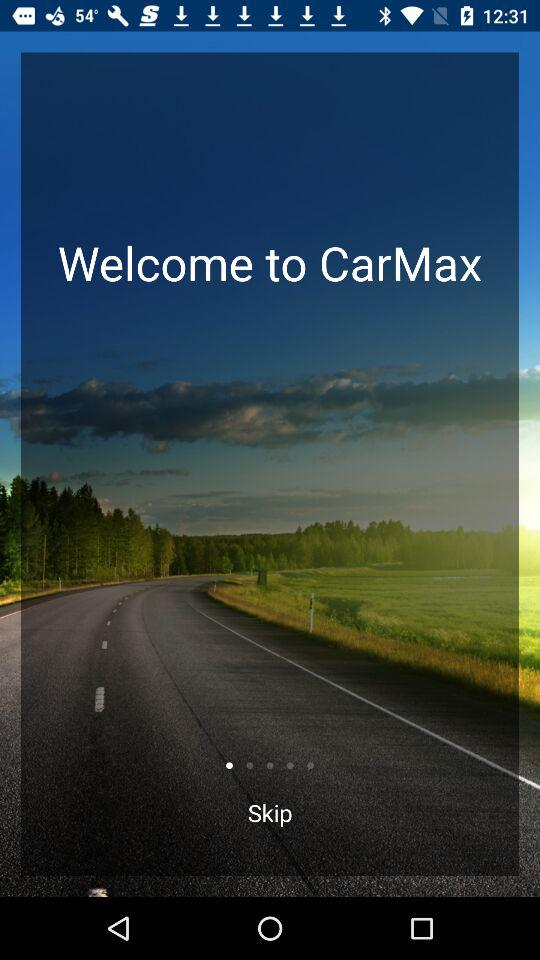What is the function of "CarMax"?
When the provided information is insufficient, respond with <no answer>. <no answer> 